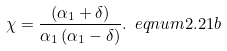<formula> <loc_0><loc_0><loc_500><loc_500>\chi = \frac { \left ( \alpha _ { 1 } + \delta \right ) } { \alpha _ { 1 } \left ( \alpha _ { 1 } - \delta \right ) } . \ e q n u m { 2 . 2 1 b }</formula> 